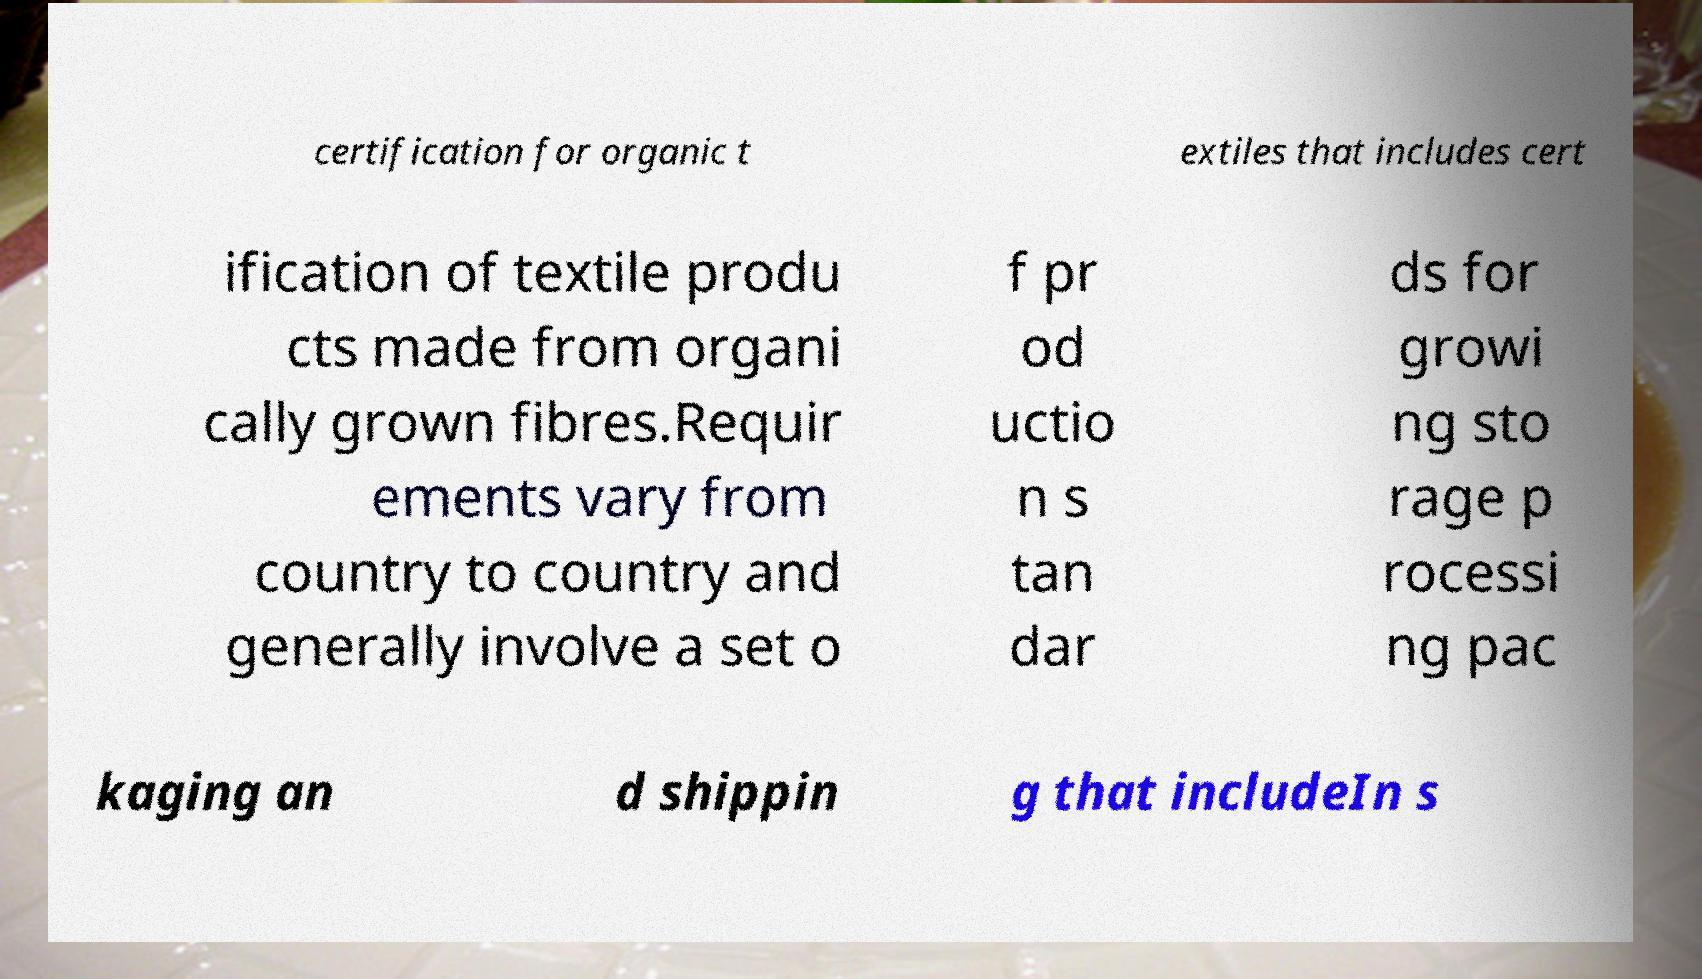Can you accurately transcribe the text from the provided image for me? certification for organic t extiles that includes cert ification of textile produ cts made from organi cally grown fibres.Requir ements vary from country to country and generally involve a set o f pr od uctio n s tan dar ds for growi ng sto rage p rocessi ng pac kaging an d shippin g that includeIn s 